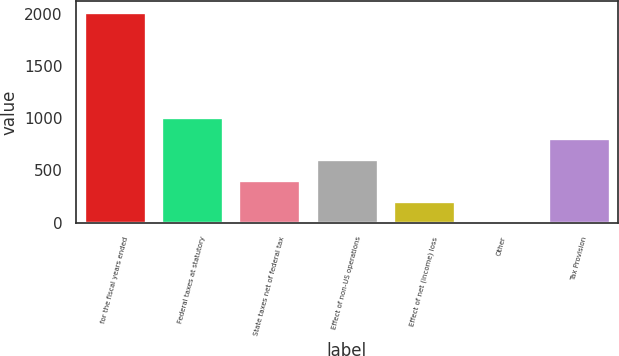<chart> <loc_0><loc_0><loc_500><loc_500><bar_chart><fcel>for the fiscal years ended<fcel>Federal taxes at statutory<fcel>State taxes net of federal tax<fcel>Effect of non-US operations<fcel>Effect of net (income) loss<fcel>Other<fcel>Tax Provision<nl><fcel>2017<fcel>1010.8<fcel>407.08<fcel>608.32<fcel>205.84<fcel>4.6<fcel>809.56<nl></chart> 